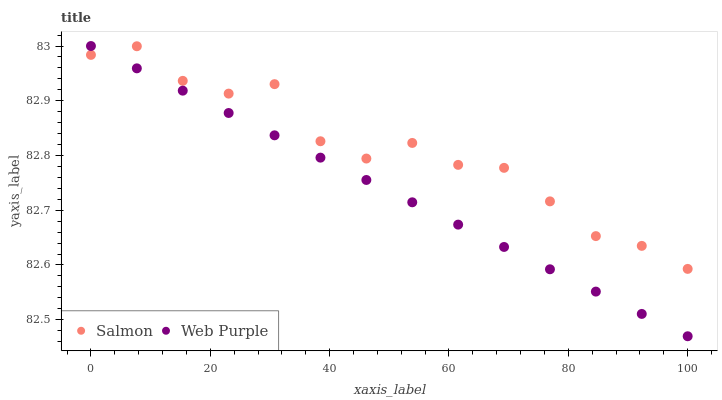Does Web Purple have the minimum area under the curve?
Answer yes or no. Yes. Does Salmon have the maximum area under the curve?
Answer yes or no. Yes. Does Salmon have the minimum area under the curve?
Answer yes or no. No. Is Web Purple the smoothest?
Answer yes or no. Yes. Is Salmon the roughest?
Answer yes or no. Yes. Is Salmon the smoothest?
Answer yes or no. No. Does Web Purple have the lowest value?
Answer yes or no. Yes. Does Salmon have the lowest value?
Answer yes or no. No. Does Web Purple have the highest value?
Answer yes or no. Yes. Does Salmon have the highest value?
Answer yes or no. No. Does Web Purple intersect Salmon?
Answer yes or no. Yes. Is Web Purple less than Salmon?
Answer yes or no. No. Is Web Purple greater than Salmon?
Answer yes or no. No. 